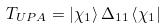Convert formula to latex. <formula><loc_0><loc_0><loc_500><loc_500>T _ { U P A } = \left | { \chi _ { 1 } } \right \rangle \Delta _ { 1 1 } \left \langle { \chi _ { 1 } } \right |</formula> 